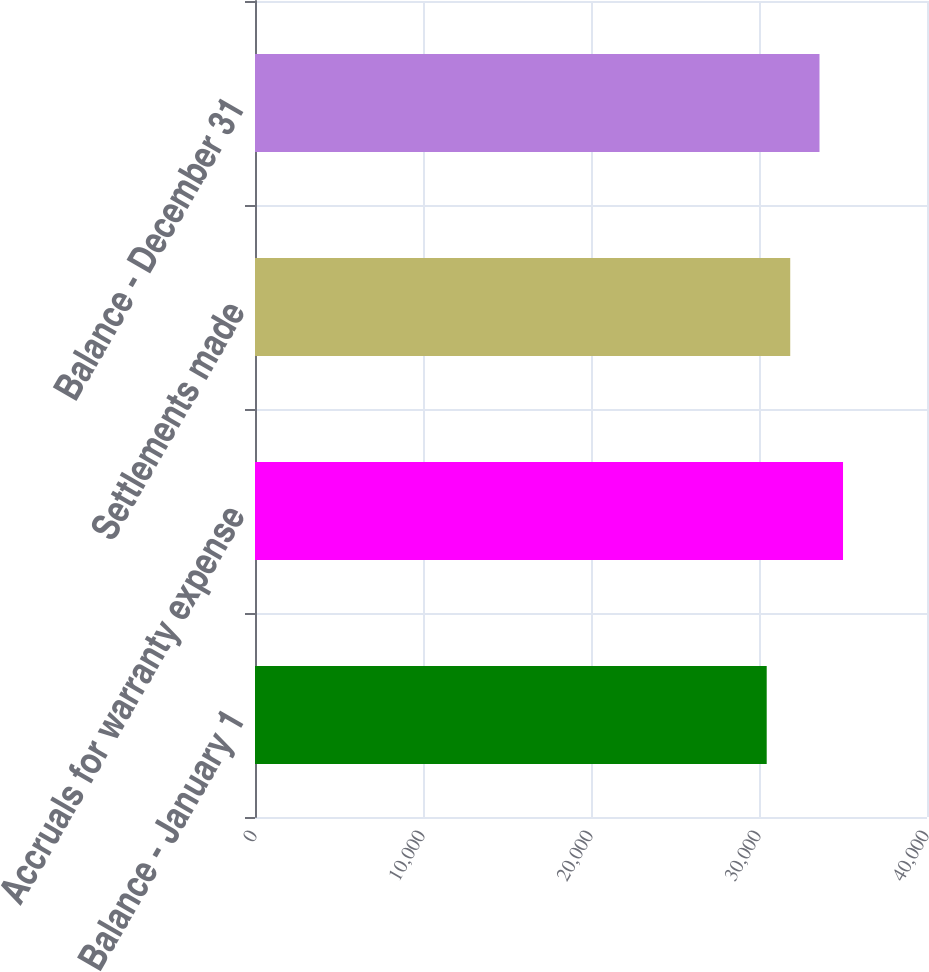<chart> <loc_0><loc_0><loc_500><loc_500><bar_chart><fcel>Balance - January 1<fcel>Accruals for warranty expense<fcel>Settlements made<fcel>Balance - December 31<nl><fcel>30459<fcel>35001<fcel>31859<fcel>33601<nl></chart> 